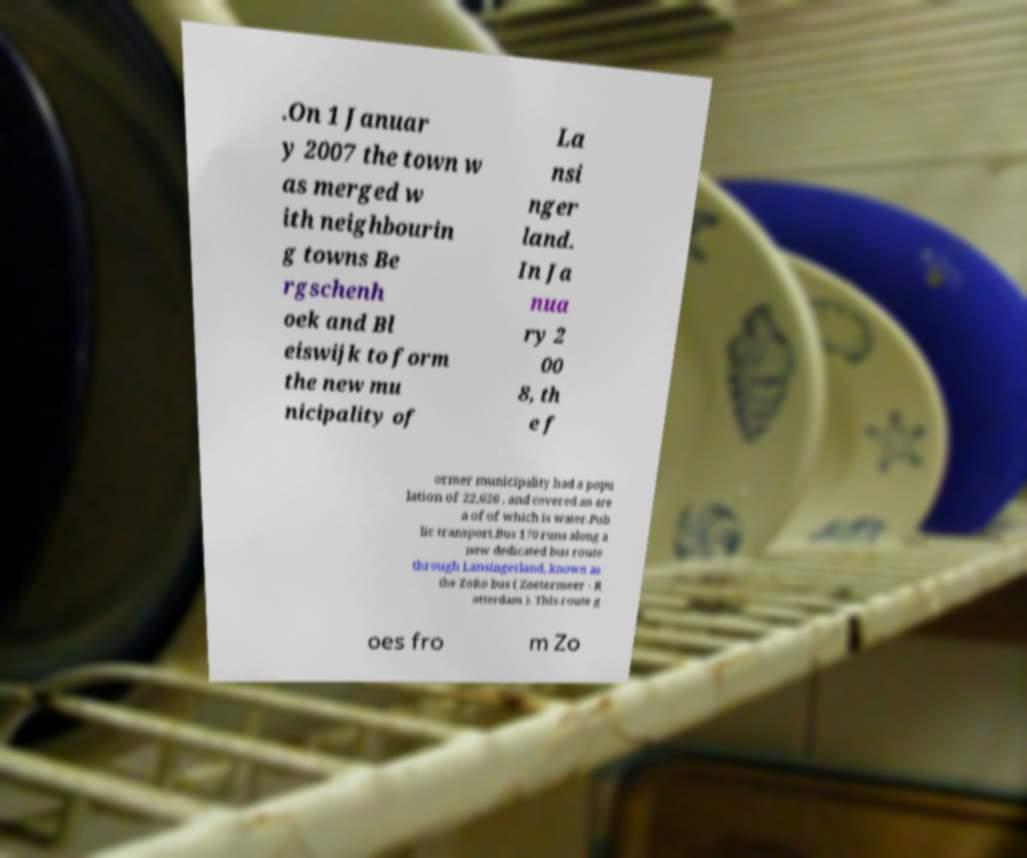Can you accurately transcribe the text from the provided image for me? .On 1 Januar y 2007 the town w as merged w ith neighbourin g towns Be rgschenh oek and Bl eiswijk to form the new mu nicipality of La nsi nger land. In Ja nua ry 2 00 8, th e f ormer municipality had a popu lation of 22,626 , and covered an are a of of which is water.Pub lic transport.Bus 170 runs along a new dedicated bus route through Lansingerland, known as the ZoRo bus ( Zoetermeer - R otterdam ). This route g oes fro m Zo 